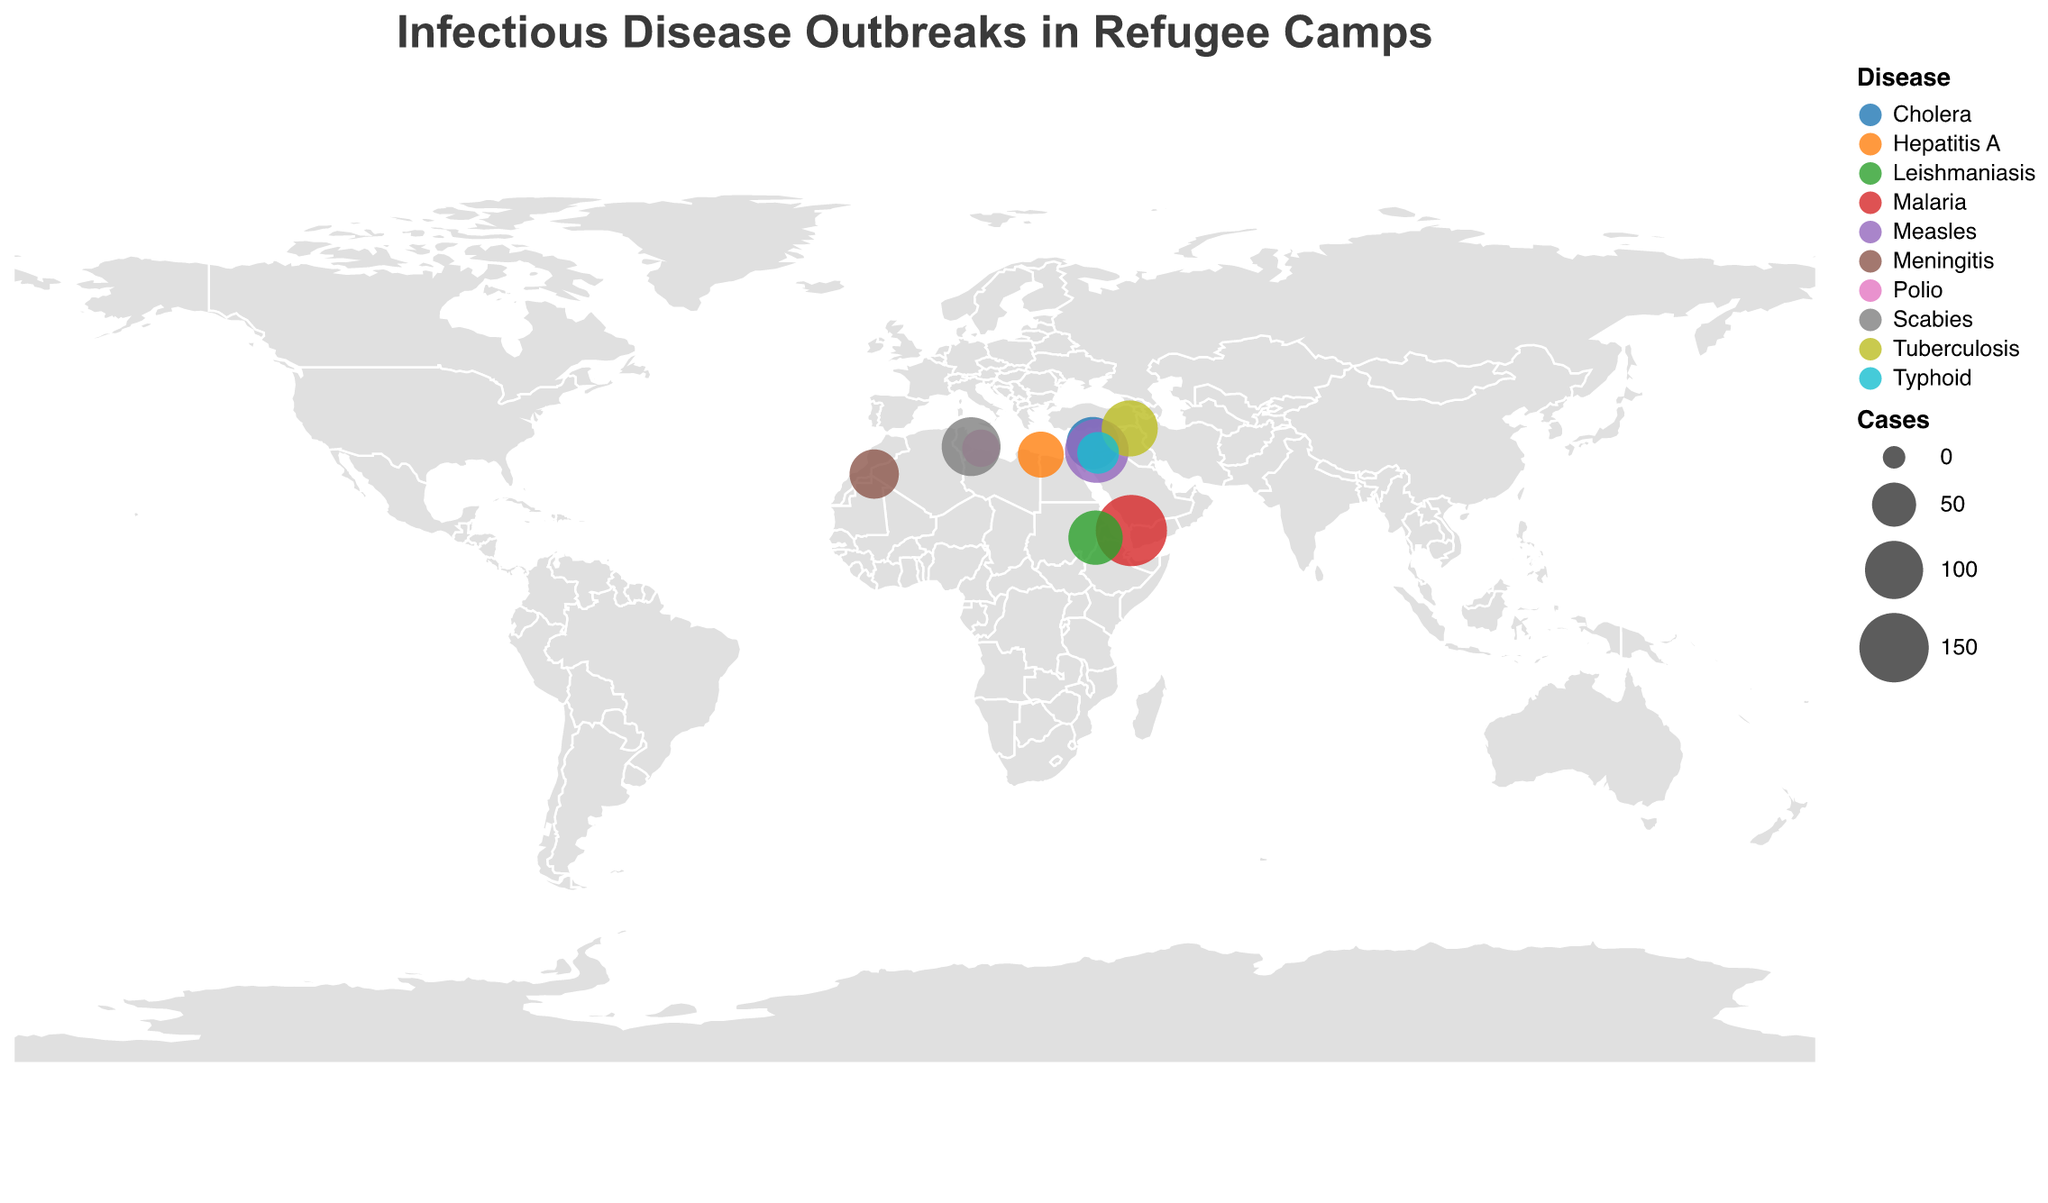What's the most recently reported disease outbreak in the data? The tooltip feature shows the diseases and years of outbreaks. The most recent year listed is 2022, for Typhoid in the Azraq camp, Syria.
Answer: Typhoid How many cases of Cholera were reported in Shatila camp, Lebanon in 2020? Hovering over the data point for Shatila camp reveals the tooltip information, showing that there were 78 cases of Cholera in 2020.
Answer: 78 Which camp in the dataset reported the highest number of cases for a single disease? By comparing the sizes of the circles on the map, the largest circle corresponds to Al Mazraq camp in Yemen with 159 cases of Malaria.
Answer: Al Mazraq What is the total number of reported disease cases across all camps? Summing all the cases listed in the tooltip: 78 + 124 + 56 + 92 + 43 + 31 + 67 + 103 + 159 + 85 = 838.
Answer: 838 Which disease was reported in the Tindouf camp, Algeria? Hovering over Tindouf camp shows the tooltip specifying that Meningitis was the reported disease.
Answer: Meningitis How does the number of Measles cases in Zaatari camp compare to the number of Scabies cases in Choucha camp? The tooltip for Zaatari camp indicates 124 cases of Measles, and the tooltip for Choucha camp indicates 103 cases of Scabies. Therefore, Measles cases in Zaatari are higher than Scabies cases in Choucha.
Answer: Measles cases are higher What are the coordinates (latitude and longitude) of the camp with a Polio outbreak? Hovering over Abu Salim camp in Libya reveals the tooltip, which states the coordinates as 32.8344 latitude and 13.1723 longitude.
Answer: 32.8344, 13.1723 How many unique diseases are represented in the data? Checking the different colors of circles on the plot and matching them with the tooltips show 10 unique diseases: Cholera, Measles, Hepatitis A, Tuberculosis, Typhoid, Polio, Meningitis, Scabies, Malaria, and Leishmaniasis.
Answer: 10 What is the average number of cases per camp for the diseases reported in 2020? The tooltip shows two camps in 2020: Shatila with 78 cases and Tindouf with 67 cases. The average is (78 + 67) / 2 = 72.5 cases.
Answer: 72.5 